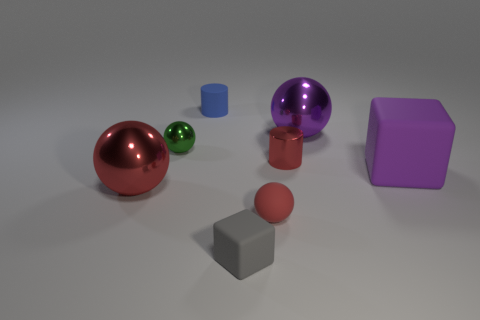What number of tiny blue matte objects are behind the shiny ball that is right of the tiny red rubber thing?
Offer a very short reply. 1. How many metallic objects are either large brown balls or red cylinders?
Provide a short and direct response. 1. Is there a tiny ball that has the same material as the tiny blue thing?
Your answer should be very brief. Yes. What number of things are either shiny balls that are right of the tiny gray object or shiny spheres on the right side of the small blue cylinder?
Offer a terse response. 1. There is a small object behind the purple metal object; is its color the same as the small cube?
Provide a succinct answer. No. How many other objects are the same color as the rubber cylinder?
Offer a terse response. 0. What is the small green object made of?
Keep it short and to the point. Metal. Does the rubber block in front of the purple rubber thing have the same size as the purple rubber object?
Keep it short and to the point. No. What is the size of the other object that is the same shape as the tiny red shiny object?
Your response must be concise. Small. Are there an equal number of cylinders in front of the large purple ball and large purple rubber things that are behind the small red sphere?
Keep it short and to the point. Yes. 